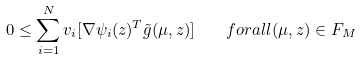Convert formula to latex. <formula><loc_0><loc_0><loc_500><loc_500>0 \leq \sum _ { i = 1 } ^ { N } v _ { i } [ \nabla \psi _ { i } ( z ) ^ { T } \tilde { g } ( \mu , z ) ] \quad f o r a l l ( \mu , z ) \in F _ { M }</formula> 